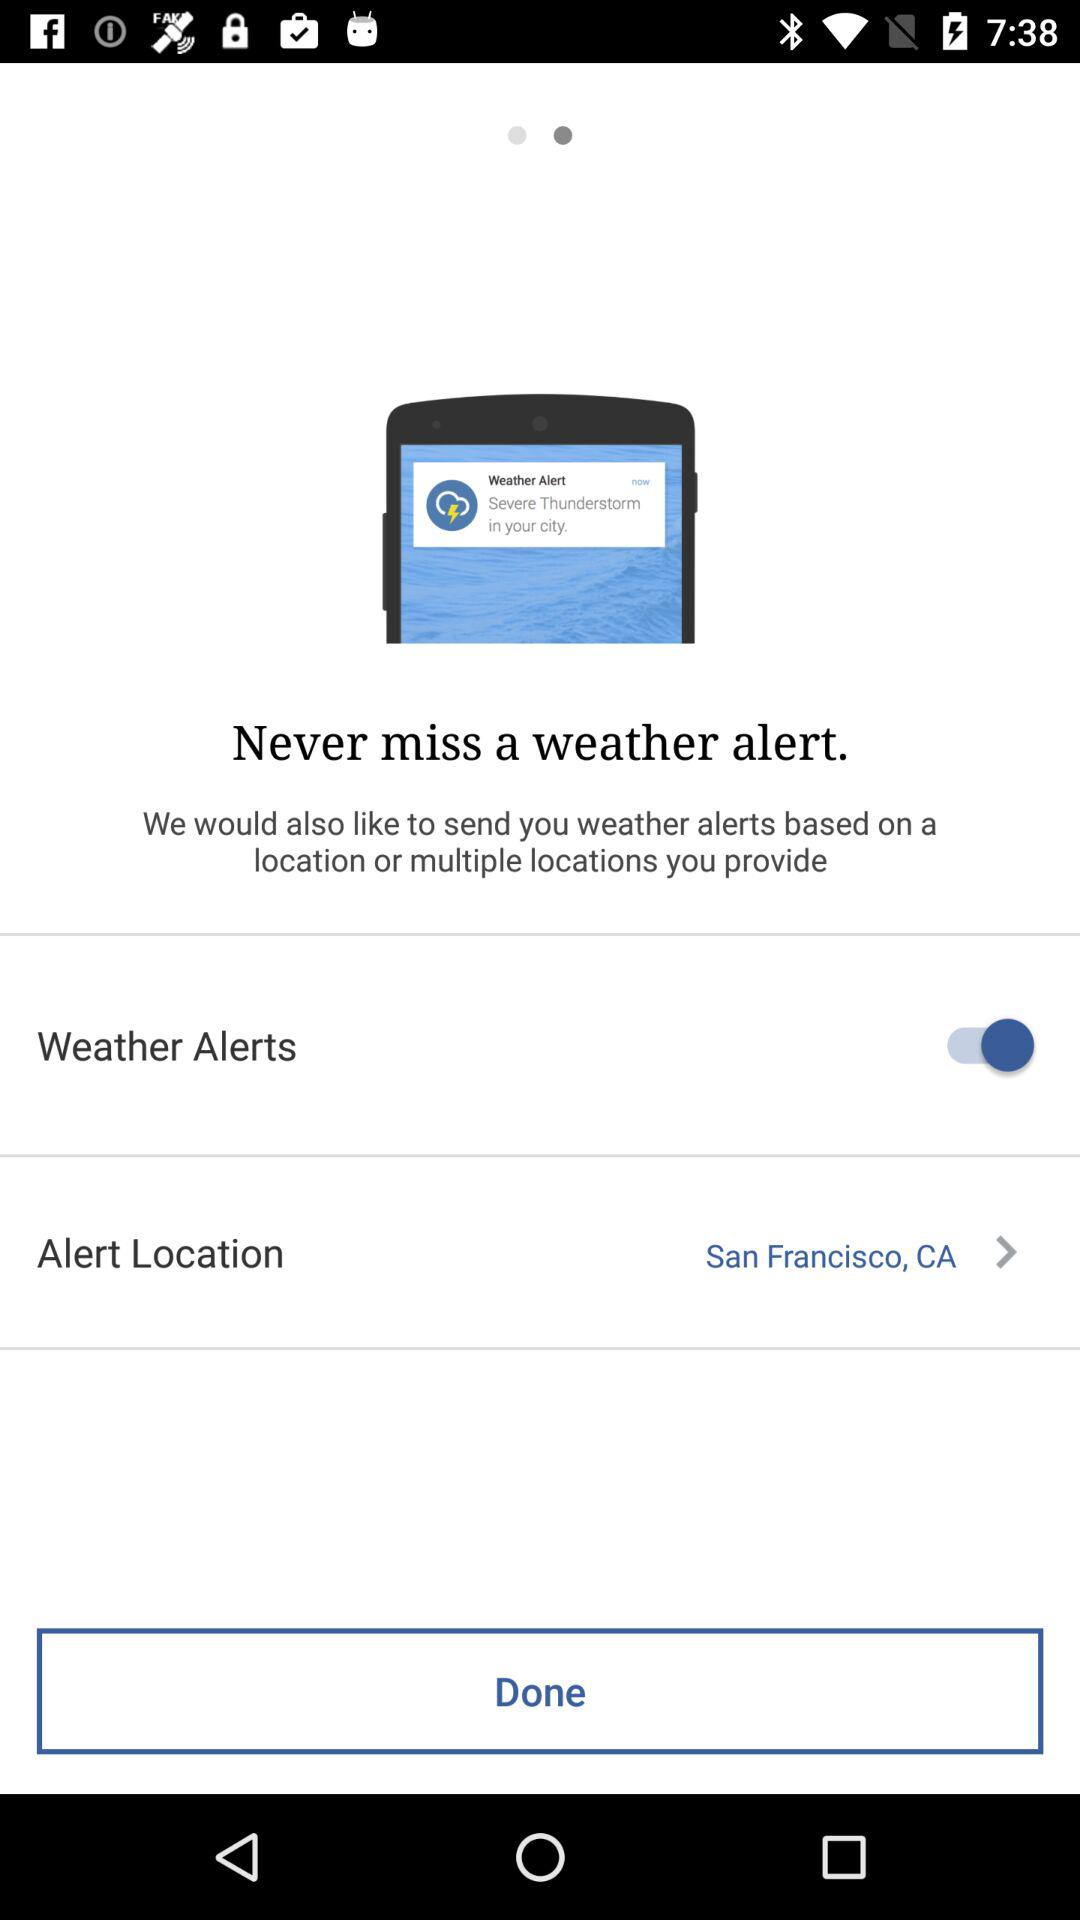What is the status of the "Weather Alerts"? The status is "on". 